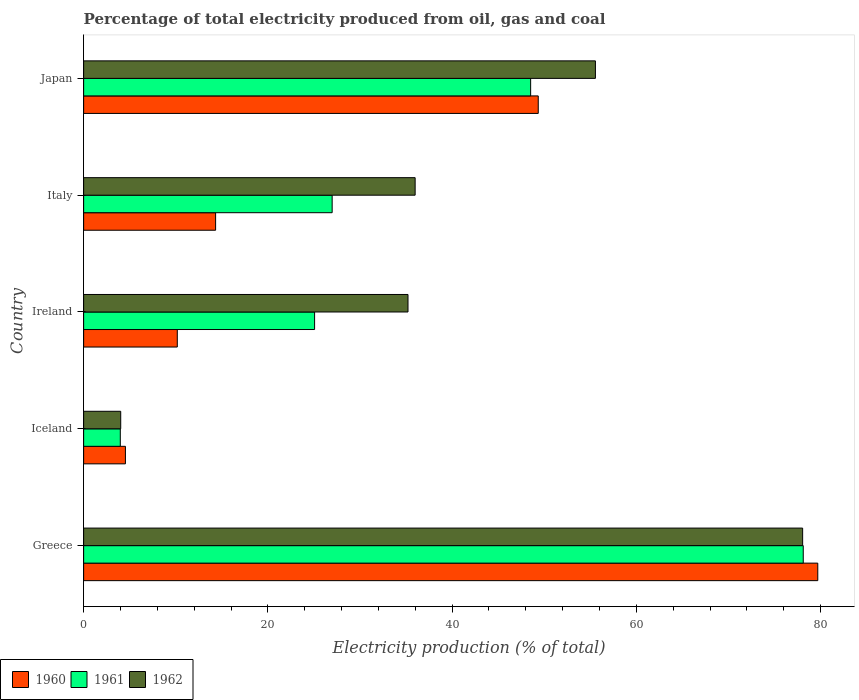Are the number of bars on each tick of the Y-axis equal?
Keep it short and to the point. Yes. What is the label of the 5th group of bars from the top?
Your answer should be very brief. Greece. In how many cases, is the number of bars for a given country not equal to the number of legend labels?
Provide a succinct answer. 0. What is the electricity production in in 1962 in Iceland?
Your response must be concise. 4.03. Across all countries, what is the maximum electricity production in in 1960?
Keep it short and to the point. 79.69. Across all countries, what is the minimum electricity production in in 1961?
Keep it short and to the point. 3.98. In which country was the electricity production in in 1962 minimum?
Your answer should be very brief. Iceland. What is the total electricity production in in 1960 in the graph?
Offer a very short reply. 158.08. What is the difference between the electricity production in in 1961 in Iceland and that in Ireland?
Make the answer very short. -21.09. What is the difference between the electricity production in in 1961 in Italy and the electricity production in in 1960 in Ireland?
Offer a terse response. 16.81. What is the average electricity production in in 1962 per country?
Your answer should be very brief. 41.77. What is the difference between the electricity production in in 1961 and electricity production in in 1962 in Ireland?
Your answer should be compact. -10.14. In how many countries, is the electricity production in in 1962 greater than 4 %?
Make the answer very short. 5. What is the ratio of the electricity production in in 1960 in Iceland to that in Japan?
Your answer should be very brief. 0.09. What is the difference between the highest and the second highest electricity production in in 1960?
Offer a terse response. 30.34. What is the difference between the highest and the lowest electricity production in in 1961?
Provide a succinct answer. 74.14. What does the 3rd bar from the bottom in Iceland represents?
Offer a very short reply. 1962. How many bars are there?
Your answer should be very brief. 15. Are all the bars in the graph horizontal?
Ensure brevity in your answer.  Yes. Are the values on the major ticks of X-axis written in scientific E-notation?
Keep it short and to the point. No. Does the graph contain grids?
Your response must be concise. No. Where does the legend appear in the graph?
Your answer should be compact. Bottom left. How many legend labels are there?
Your answer should be compact. 3. What is the title of the graph?
Provide a succinct answer. Percentage of total electricity produced from oil, gas and coal. Does "1995" appear as one of the legend labels in the graph?
Provide a short and direct response. No. What is the label or title of the X-axis?
Give a very brief answer. Electricity production (% of total). What is the label or title of the Y-axis?
Offer a very short reply. Country. What is the Electricity production (% of total) in 1960 in Greece?
Provide a short and direct response. 79.69. What is the Electricity production (% of total) in 1961 in Greece?
Offer a very short reply. 78.12. What is the Electricity production (% of total) in 1962 in Greece?
Provide a succinct answer. 78.05. What is the Electricity production (% of total) in 1960 in Iceland?
Provide a short and direct response. 4.54. What is the Electricity production (% of total) of 1961 in Iceland?
Make the answer very short. 3.98. What is the Electricity production (% of total) of 1962 in Iceland?
Ensure brevity in your answer.  4.03. What is the Electricity production (% of total) of 1960 in Ireland?
Offer a very short reply. 10.17. What is the Electricity production (% of total) of 1961 in Ireland?
Make the answer very short. 25.07. What is the Electricity production (% of total) in 1962 in Ireland?
Your response must be concise. 35.21. What is the Electricity production (% of total) of 1960 in Italy?
Your answer should be very brief. 14.33. What is the Electricity production (% of total) in 1961 in Italy?
Give a very brief answer. 26.98. What is the Electricity production (% of total) in 1962 in Italy?
Provide a succinct answer. 35.99. What is the Electricity production (% of total) in 1960 in Japan?
Your response must be concise. 49.35. What is the Electricity production (% of total) of 1961 in Japan?
Provide a short and direct response. 48.52. What is the Electricity production (% of total) of 1962 in Japan?
Keep it short and to the point. 55.56. Across all countries, what is the maximum Electricity production (% of total) in 1960?
Ensure brevity in your answer.  79.69. Across all countries, what is the maximum Electricity production (% of total) in 1961?
Your response must be concise. 78.12. Across all countries, what is the maximum Electricity production (% of total) of 1962?
Offer a very short reply. 78.05. Across all countries, what is the minimum Electricity production (% of total) in 1960?
Give a very brief answer. 4.54. Across all countries, what is the minimum Electricity production (% of total) in 1961?
Provide a succinct answer. 3.98. Across all countries, what is the minimum Electricity production (% of total) of 1962?
Your answer should be compact. 4.03. What is the total Electricity production (% of total) of 1960 in the graph?
Ensure brevity in your answer.  158.08. What is the total Electricity production (% of total) of 1961 in the graph?
Offer a very short reply. 182.67. What is the total Electricity production (% of total) of 1962 in the graph?
Offer a terse response. 208.83. What is the difference between the Electricity production (% of total) in 1960 in Greece and that in Iceland?
Keep it short and to the point. 75.16. What is the difference between the Electricity production (% of total) in 1961 in Greece and that in Iceland?
Give a very brief answer. 74.14. What is the difference between the Electricity production (% of total) of 1962 in Greece and that in Iceland?
Provide a short and direct response. 74.02. What is the difference between the Electricity production (% of total) of 1960 in Greece and that in Ireland?
Provide a succinct answer. 69.53. What is the difference between the Electricity production (% of total) in 1961 in Greece and that in Ireland?
Provide a succinct answer. 53.05. What is the difference between the Electricity production (% of total) of 1962 in Greece and that in Ireland?
Offer a very short reply. 42.84. What is the difference between the Electricity production (% of total) of 1960 in Greece and that in Italy?
Offer a terse response. 65.37. What is the difference between the Electricity production (% of total) of 1961 in Greece and that in Italy?
Make the answer very short. 51.14. What is the difference between the Electricity production (% of total) in 1962 in Greece and that in Italy?
Give a very brief answer. 42.06. What is the difference between the Electricity production (% of total) in 1960 in Greece and that in Japan?
Provide a short and direct response. 30.34. What is the difference between the Electricity production (% of total) of 1961 in Greece and that in Japan?
Offer a terse response. 29.59. What is the difference between the Electricity production (% of total) in 1962 in Greece and that in Japan?
Your response must be concise. 22.49. What is the difference between the Electricity production (% of total) in 1960 in Iceland and that in Ireland?
Your response must be concise. -5.63. What is the difference between the Electricity production (% of total) in 1961 in Iceland and that in Ireland?
Your response must be concise. -21.09. What is the difference between the Electricity production (% of total) in 1962 in Iceland and that in Ireland?
Your response must be concise. -31.19. What is the difference between the Electricity production (% of total) of 1960 in Iceland and that in Italy?
Offer a very short reply. -9.79. What is the difference between the Electricity production (% of total) of 1961 in Iceland and that in Italy?
Your response must be concise. -23. What is the difference between the Electricity production (% of total) of 1962 in Iceland and that in Italy?
Your answer should be compact. -31.96. What is the difference between the Electricity production (% of total) in 1960 in Iceland and that in Japan?
Your answer should be compact. -44.81. What is the difference between the Electricity production (% of total) in 1961 in Iceland and that in Japan?
Keep it short and to the point. -44.54. What is the difference between the Electricity production (% of total) of 1962 in Iceland and that in Japan?
Ensure brevity in your answer.  -51.53. What is the difference between the Electricity production (% of total) of 1960 in Ireland and that in Italy?
Your answer should be very brief. -4.16. What is the difference between the Electricity production (% of total) in 1961 in Ireland and that in Italy?
Your answer should be very brief. -1.91. What is the difference between the Electricity production (% of total) of 1962 in Ireland and that in Italy?
Ensure brevity in your answer.  -0.78. What is the difference between the Electricity production (% of total) in 1960 in Ireland and that in Japan?
Ensure brevity in your answer.  -39.18. What is the difference between the Electricity production (% of total) in 1961 in Ireland and that in Japan?
Provide a succinct answer. -23.45. What is the difference between the Electricity production (% of total) in 1962 in Ireland and that in Japan?
Provide a succinct answer. -20.34. What is the difference between the Electricity production (% of total) of 1960 in Italy and that in Japan?
Your answer should be very brief. -35.02. What is the difference between the Electricity production (% of total) of 1961 in Italy and that in Japan?
Offer a terse response. -21.55. What is the difference between the Electricity production (% of total) of 1962 in Italy and that in Japan?
Keep it short and to the point. -19.57. What is the difference between the Electricity production (% of total) of 1960 in Greece and the Electricity production (% of total) of 1961 in Iceland?
Provide a short and direct response. 75.71. What is the difference between the Electricity production (% of total) of 1960 in Greece and the Electricity production (% of total) of 1962 in Iceland?
Provide a succinct answer. 75.67. What is the difference between the Electricity production (% of total) of 1961 in Greece and the Electricity production (% of total) of 1962 in Iceland?
Provide a succinct answer. 74.09. What is the difference between the Electricity production (% of total) in 1960 in Greece and the Electricity production (% of total) in 1961 in Ireland?
Provide a succinct answer. 54.62. What is the difference between the Electricity production (% of total) in 1960 in Greece and the Electricity production (% of total) in 1962 in Ireland?
Your answer should be very brief. 44.48. What is the difference between the Electricity production (% of total) of 1961 in Greece and the Electricity production (% of total) of 1962 in Ireland?
Provide a succinct answer. 42.91. What is the difference between the Electricity production (% of total) of 1960 in Greece and the Electricity production (% of total) of 1961 in Italy?
Your answer should be compact. 52.72. What is the difference between the Electricity production (% of total) of 1960 in Greece and the Electricity production (% of total) of 1962 in Italy?
Your answer should be very brief. 43.71. What is the difference between the Electricity production (% of total) in 1961 in Greece and the Electricity production (% of total) in 1962 in Italy?
Offer a terse response. 42.13. What is the difference between the Electricity production (% of total) in 1960 in Greece and the Electricity production (% of total) in 1961 in Japan?
Your answer should be compact. 31.17. What is the difference between the Electricity production (% of total) in 1960 in Greece and the Electricity production (% of total) in 1962 in Japan?
Your answer should be very brief. 24.14. What is the difference between the Electricity production (% of total) in 1961 in Greece and the Electricity production (% of total) in 1962 in Japan?
Provide a short and direct response. 22.56. What is the difference between the Electricity production (% of total) in 1960 in Iceland and the Electricity production (% of total) in 1961 in Ireland?
Keep it short and to the point. -20.53. What is the difference between the Electricity production (% of total) of 1960 in Iceland and the Electricity production (% of total) of 1962 in Ireland?
Offer a very short reply. -30.67. What is the difference between the Electricity production (% of total) in 1961 in Iceland and the Electricity production (% of total) in 1962 in Ireland?
Keep it short and to the point. -31.23. What is the difference between the Electricity production (% of total) of 1960 in Iceland and the Electricity production (% of total) of 1961 in Italy?
Offer a very short reply. -22.44. What is the difference between the Electricity production (% of total) of 1960 in Iceland and the Electricity production (% of total) of 1962 in Italy?
Offer a terse response. -31.45. What is the difference between the Electricity production (% of total) in 1961 in Iceland and the Electricity production (% of total) in 1962 in Italy?
Give a very brief answer. -32.01. What is the difference between the Electricity production (% of total) of 1960 in Iceland and the Electricity production (% of total) of 1961 in Japan?
Keep it short and to the point. -43.99. What is the difference between the Electricity production (% of total) in 1960 in Iceland and the Electricity production (% of total) in 1962 in Japan?
Ensure brevity in your answer.  -51.02. What is the difference between the Electricity production (% of total) in 1961 in Iceland and the Electricity production (% of total) in 1962 in Japan?
Give a very brief answer. -51.58. What is the difference between the Electricity production (% of total) of 1960 in Ireland and the Electricity production (% of total) of 1961 in Italy?
Provide a short and direct response. -16.81. What is the difference between the Electricity production (% of total) in 1960 in Ireland and the Electricity production (% of total) in 1962 in Italy?
Your answer should be very brief. -25.82. What is the difference between the Electricity production (% of total) of 1961 in Ireland and the Electricity production (% of total) of 1962 in Italy?
Give a very brief answer. -10.92. What is the difference between the Electricity production (% of total) in 1960 in Ireland and the Electricity production (% of total) in 1961 in Japan?
Provide a succinct answer. -38.36. What is the difference between the Electricity production (% of total) of 1960 in Ireland and the Electricity production (% of total) of 1962 in Japan?
Your answer should be compact. -45.39. What is the difference between the Electricity production (% of total) of 1961 in Ireland and the Electricity production (% of total) of 1962 in Japan?
Offer a terse response. -30.48. What is the difference between the Electricity production (% of total) in 1960 in Italy and the Electricity production (% of total) in 1961 in Japan?
Offer a very short reply. -34.2. What is the difference between the Electricity production (% of total) in 1960 in Italy and the Electricity production (% of total) in 1962 in Japan?
Keep it short and to the point. -41.23. What is the difference between the Electricity production (% of total) in 1961 in Italy and the Electricity production (% of total) in 1962 in Japan?
Provide a short and direct response. -28.58. What is the average Electricity production (% of total) in 1960 per country?
Give a very brief answer. 31.62. What is the average Electricity production (% of total) of 1961 per country?
Offer a terse response. 36.53. What is the average Electricity production (% of total) of 1962 per country?
Give a very brief answer. 41.77. What is the difference between the Electricity production (% of total) in 1960 and Electricity production (% of total) in 1961 in Greece?
Make the answer very short. 1.58. What is the difference between the Electricity production (% of total) in 1960 and Electricity production (% of total) in 1962 in Greece?
Offer a very short reply. 1.64. What is the difference between the Electricity production (% of total) of 1961 and Electricity production (% of total) of 1962 in Greece?
Your response must be concise. 0.07. What is the difference between the Electricity production (% of total) in 1960 and Electricity production (% of total) in 1961 in Iceland?
Your response must be concise. 0.56. What is the difference between the Electricity production (% of total) of 1960 and Electricity production (% of total) of 1962 in Iceland?
Provide a short and direct response. 0.51. What is the difference between the Electricity production (% of total) of 1961 and Electricity production (% of total) of 1962 in Iceland?
Make the answer very short. -0.05. What is the difference between the Electricity production (% of total) of 1960 and Electricity production (% of total) of 1961 in Ireland?
Your response must be concise. -14.9. What is the difference between the Electricity production (% of total) of 1960 and Electricity production (% of total) of 1962 in Ireland?
Offer a terse response. -25.04. What is the difference between the Electricity production (% of total) of 1961 and Electricity production (% of total) of 1962 in Ireland?
Offer a very short reply. -10.14. What is the difference between the Electricity production (% of total) in 1960 and Electricity production (% of total) in 1961 in Italy?
Provide a succinct answer. -12.65. What is the difference between the Electricity production (% of total) in 1960 and Electricity production (% of total) in 1962 in Italy?
Your answer should be very brief. -21.66. What is the difference between the Electricity production (% of total) of 1961 and Electricity production (% of total) of 1962 in Italy?
Your answer should be compact. -9.01. What is the difference between the Electricity production (% of total) of 1960 and Electricity production (% of total) of 1961 in Japan?
Keep it short and to the point. 0.83. What is the difference between the Electricity production (% of total) in 1960 and Electricity production (% of total) in 1962 in Japan?
Your response must be concise. -6.2. What is the difference between the Electricity production (% of total) of 1961 and Electricity production (% of total) of 1962 in Japan?
Ensure brevity in your answer.  -7.03. What is the ratio of the Electricity production (% of total) of 1960 in Greece to that in Iceland?
Your answer should be compact. 17.56. What is the ratio of the Electricity production (% of total) of 1961 in Greece to that in Iceland?
Your answer should be very brief. 19.63. What is the ratio of the Electricity production (% of total) of 1962 in Greece to that in Iceland?
Your answer should be compact. 19.39. What is the ratio of the Electricity production (% of total) in 1960 in Greece to that in Ireland?
Your response must be concise. 7.84. What is the ratio of the Electricity production (% of total) of 1961 in Greece to that in Ireland?
Give a very brief answer. 3.12. What is the ratio of the Electricity production (% of total) in 1962 in Greece to that in Ireland?
Provide a succinct answer. 2.22. What is the ratio of the Electricity production (% of total) of 1960 in Greece to that in Italy?
Ensure brevity in your answer.  5.56. What is the ratio of the Electricity production (% of total) in 1961 in Greece to that in Italy?
Ensure brevity in your answer.  2.9. What is the ratio of the Electricity production (% of total) in 1962 in Greece to that in Italy?
Make the answer very short. 2.17. What is the ratio of the Electricity production (% of total) in 1960 in Greece to that in Japan?
Provide a short and direct response. 1.61. What is the ratio of the Electricity production (% of total) of 1961 in Greece to that in Japan?
Ensure brevity in your answer.  1.61. What is the ratio of the Electricity production (% of total) of 1962 in Greece to that in Japan?
Your response must be concise. 1.4. What is the ratio of the Electricity production (% of total) of 1960 in Iceland to that in Ireland?
Your response must be concise. 0.45. What is the ratio of the Electricity production (% of total) in 1961 in Iceland to that in Ireland?
Ensure brevity in your answer.  0.16. What is the ratio of the Electricity production (% of total) in 1962 in Iceland to that in Ireland?
Give a very brief answer. 0.11. What is the ratio of the Electricity production (% of total) in 1960 in Iceland to that in Italy?
Provide a short and direct response. 0.32. What is the ratio of the Electricity production (% of total) of 1961 in Iceland to that in Italy?
Keep it short and to the point. 0.15. What is the ratio of the Electricity production (% of total) of 1962 in Iceland to that in Italy?
Your answer should be compact. 0.11. What is the ratio of the Electricity production (% of total) in 1960 in Iceland to that in Japan?
Offer a very short reply. 0.09. What is the ratio of the Electricity production (% of total) in 1961 in Iceland to that in Japan?
Give a very brief answer. 0.08. What is the ratio of the Electricity production (% of total) of 1962 in Iceland to that in Japan?
Keep it short and to the point. 0.07. What is the ratio of the Electricity production (% of total) of 1960 in Ireland to that in Italy?
Your answer should be compact. 0.71. What is the ratio of the Electricity production (% of total) in 1961 in Ireland to that in Italy?
Offer a very short reply. 0.93. What is the ratio of the Electricity production (% of total) of 1962 in Ireland to that in Italy?
Make the answer very short. 0.98. What is the ratio of the Electricity production (% of total) of 1960 in Ireland to that in Japan?
Your answer should be very brief. 0.21. What is the ratio of the Electricity production (% of total) of 1961 in Ireland to that in Japan?
Offer a very short reply. 0.52. What is the ratio of the Electricity production (% of total) in 1962 in Ireland to that in Japan?
Offer a terse response. 0.63. What is the ratio of the Electricity production (% of total) of 1960 in Italy to that in Japan?
Offer a very short reply. 0.29. What is the ratio of the Electricity production (% of total) in 1961 in Italy to that in Japan?
Give a very brief answer. 0.56. What is the ratio of the Electricity production (% of total) of 1962 in Italy to that in Japan?
Give a very brief answer. 0.65. What is the difference between the highest and the second highest Electricity production (% of total) of 1960?
Offer a very short reply. 30.34. What is the difference between the highest and the second highest Electricity production (% of total) in 1961?
Your answer should be very brief. 29.59. What is the difference between the highest and the second highest Electricity production (% of total) of 1962?
Ensure brevity in your answer.  22.49. What is the difference between the highest and the lowest Electricity production (% of total) of 1960?
Make the answer very short. 75.16. What is the difference between the highest and the lowest Electricity production (% of total) of 1961?
Offer a very short reply. 74.14. What is the difference between the highest and the lowest Electricity production (% of total) in 1962?
Your response must be concise. 74.02. 